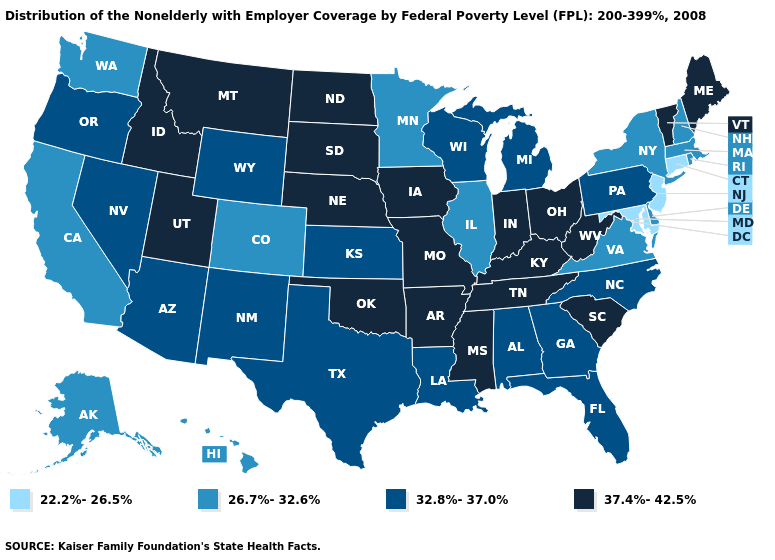Among the states that border Virginia , does West Virginia have the highest value?
Short answer required. Yes. Which states have the lowest value in the MidWest?
Answer briefly. Illinois, Minnesota. Name the states that have a value in the range 26.7%-32.6%?
Keep it brief. Alaska, California, Colorado, Delaware, Hawaii, Illinois, Massachusetts, Minnesota, New Hampshire, New York, Rhode Island, Virginia, Washington. Name the states that have a value in the range 32.8%-37.0%?
Short answer required. Alabama, Arizona, Florida, Georgia, Kansas, Louisiana, Michigan, Nevada, New Mexico, North Carolina, Oregon, Pennsylvania, Texas, Wisconsin, Wyoming. Does Minnesota have the lowest value in the MidWest?
Quick response, please. Yes. Which states have the highest value in the USA?
Keep it brief. Arkansas, Idaho, Indiana, Iowa, Kentucky, Maine, Mississippi, Missouri, Montana, Nebraska, North Dakota, Ohio, Oklahoma, South Carolina, South Dakota, Tennessee, Utah, Vermont, West Virginia. Name the states that have a value in the range 32.8%-37.0%?
Be succinct. Alabama, Arizona, Florida, Georgia, Kansas, Louisiana, Michigan, Nevada, New Mexico, North Carolina, Oregon, Pennsylvania, Texas, Wisconsin, Wyoming. Which states have the highest value in the USA?
Quick response, please. Arkansas, Idaho, Indiana, Iowa, Kentucky, Maine, Mississippi, Missouri, Montana, Nebraska, North Dakota, Ohio, Oklahoma, South Carolina, South Dakota, Tennessee, Utah, Vermont, West Virginia. Which states have the highest value in the USA?
Give a very brief answer. Arkansas, Idaho, Indiana, Iowa, Kentucky, Maine, Mississippi, Missouri, Montana, Nebraska, North Dakota, Ohio, Oklahoma, South Carolina, South Dakota, Tennessee, Utah, Vermont, West Virginia. Does Delaware have the lowest value in the USA?
Write a very short answer. No. Which states have the highest value in the USA?
Quick response, please. Arkansas, Idaho, Indiana, Iowa, Kentucky, Maine, Mississippi, Missouri, Montana, Nebraska, North Dakota, Ohio, Oklahoma, South Carolina, South Dakota, Tennessee, Utah, Vermont, West Virginia. Does Louisiana have the lowest value in the South?
Give a very brief answer. No. Name the states that have a value in the range 32.8%-37.0%?
Quick response, please. Alabama, Arizona, Florida, Georgia, Kansas, Louisiana, Michigan, Nevada, New Mexico, North Carolina, Oregon, Pennsylvania, Texas, Wisconsin, Wyoming. What is the value of Missouri?
Keep it brief. 37.4%-42.5%. Name the states that have a value in the range 37.4%-42.5%?
Answer briefly. Arkansas, Idaho, Indiana, Iowa, Kentucky, Maine, Mississippi, Missouri, Montana, Nebraska, North Dakota, Ohio, Oklahoma, South Carolina, South Dakota, Tennessee, Utah, Vermont, West Virginia. 